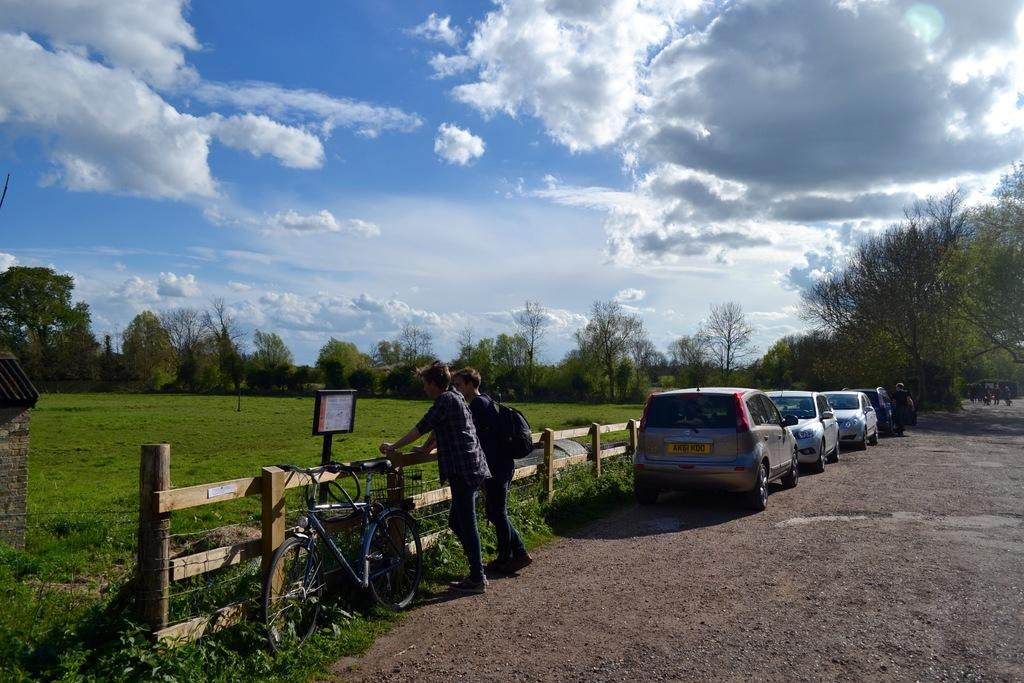What can be seen on the road in the image? There are cars on a road in the image. What are the two people near in the image? Two people are standing near a wooden railing. What type of vehicle is also visible in the image? There is a cycle in the image. What is visible in the background of the image? There is a grassland, trees, and the sky visible in the background of the image. What type of plate is being used to celebrate the birthday in the image? There is no plate or birthday celebration present in the image. How are the people washing the cycle in the image? There is no washing or cycle being washed in the image; it only shows the cycle parked. 